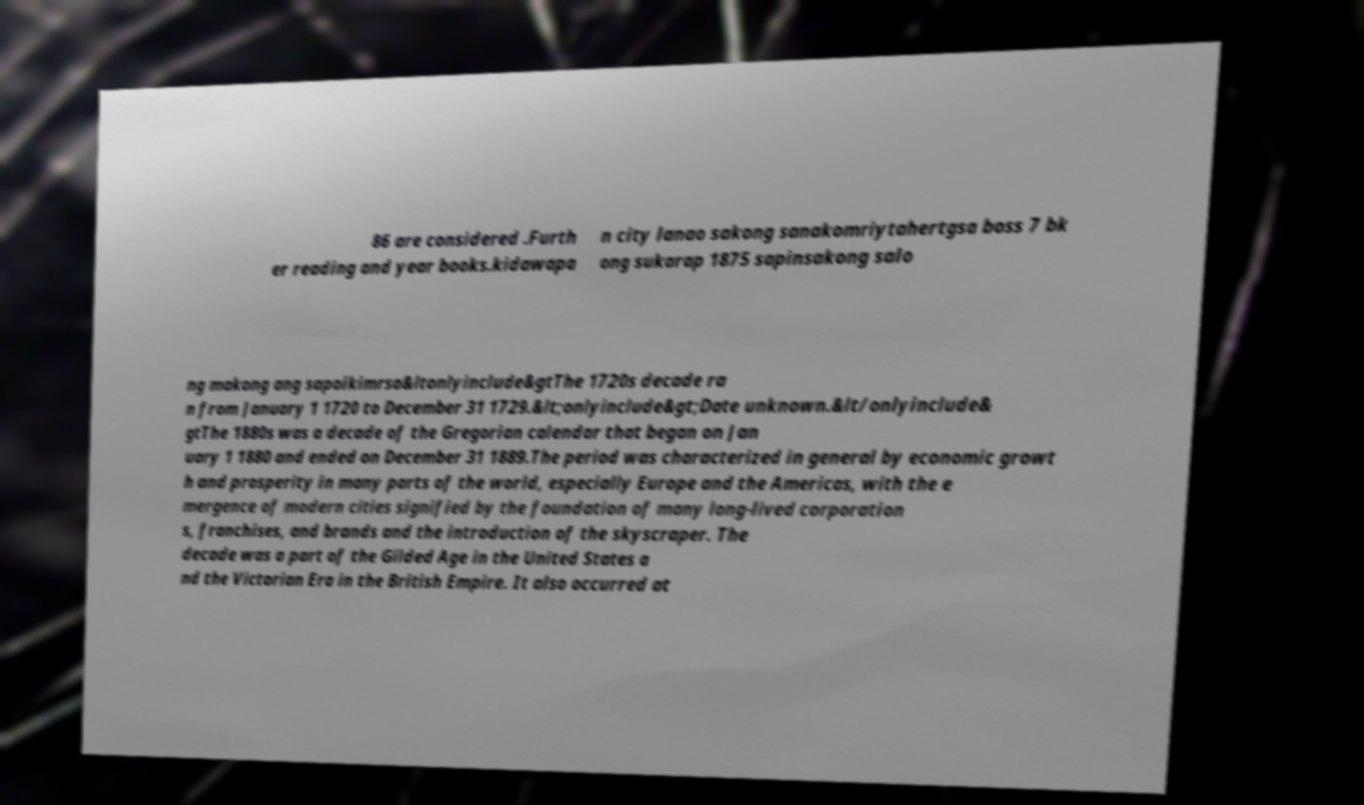Please read and relay the text visible in this image. What does it say? 86 are considered .Furth er reading and year books.kidawapa n city lanao sakong sanakomriytahertgsa boss 7 bk ong sukarap 1875 sapinsakong salo ng makong ang sapoikimrsa&ltonlyinclude&gtThe 1720s decade ra n from January 1 1720 to December 31 1729.&lt;onlyinclude&gt;Date unknown.&lt/onlyinclude& gtThe 1880s was a decade of the Gregorian calendar that began on Jan uary 1 1880 and ended on December 31 1889.The period was characterized in general by economic growt h and prosperity in many parts of the world, especially Europe and the Americas, with the e mergence of modern cities signified by the foundation of many long-lived corporation s, franchises, and brands and the introduction of the skyscraper. The decade was a part of the Gilded Age in the United States a nd the Victorian Era in the British Empire. It also occurred at 